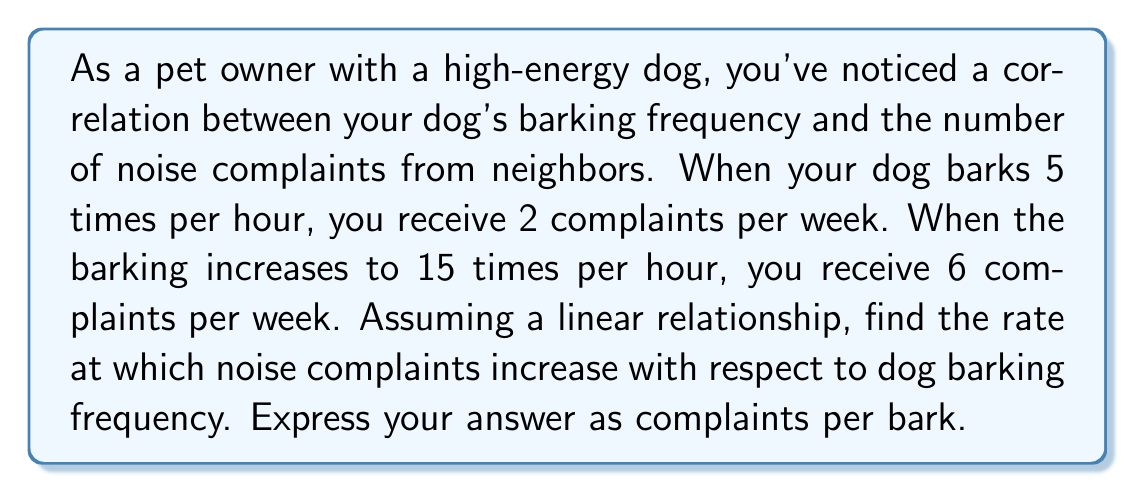Can you answer this question? To solve this problem, we can use the point-slope form of a linear equation. Let's define our variables:

$x$ = number of barks per hour
$y$ = number of complaints per week

We have two points:
$(x_1, y_1) = (5, 2)$ and $(x_2, y_2) = (15, 6)$

The slope (rate of change) formula is:

$$m = \frac{y_2 - y_1}{x_2 - x_1}$$

Plugging in our values:

$$m = \frac{6 - 2}{15 - 5} = \frac{4}{10} = 0.4$$

This means that for every additional bark per hour, the number of complaints per week increases by 0.4.

To express this as complaints per bark, we need to consider that the given data is in barks per hour and complaints per week. We can convert this to complaints per bark by dividing 0.4 complaints/week per bark/hour by 168 hours/week:

$$\frac{0.4 \text{ complaints/week}}{1 \text{ bark/hour}} \cdot \frac{1 \text{ week}}{168 \text{ hours}} = \frac{0.4}{168} \approx 0.00238 \text{ complaints/bark}$$

Therefore, the rate at which noise complaints increase is approximately 0.00238 complaints per bark.
Answer: The rate at which noise complaints increase with respect to dog barking frequency is approximately 0.00238 complaints per bark. 